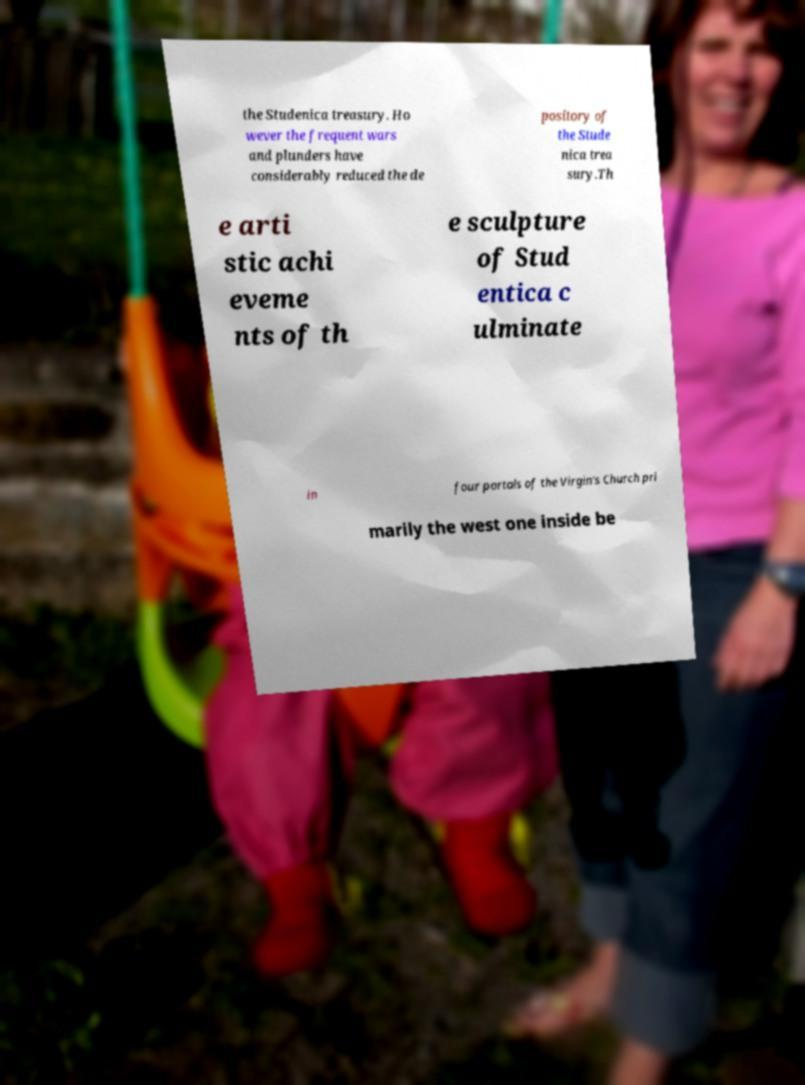Can you read and provide the text displayed in the image?This photo seems to have some interesting text. Can you extract and type it out for me? the Studenica treasury. Ho wever the frequent wars and plunders have considerably reduced the de pository of the Stude nica trea sury.Th e arti stic achi eveme nts of th e sculpture of Stud entica c ulminate in four portals of the Virgin's Church pri marily the west one inside be 